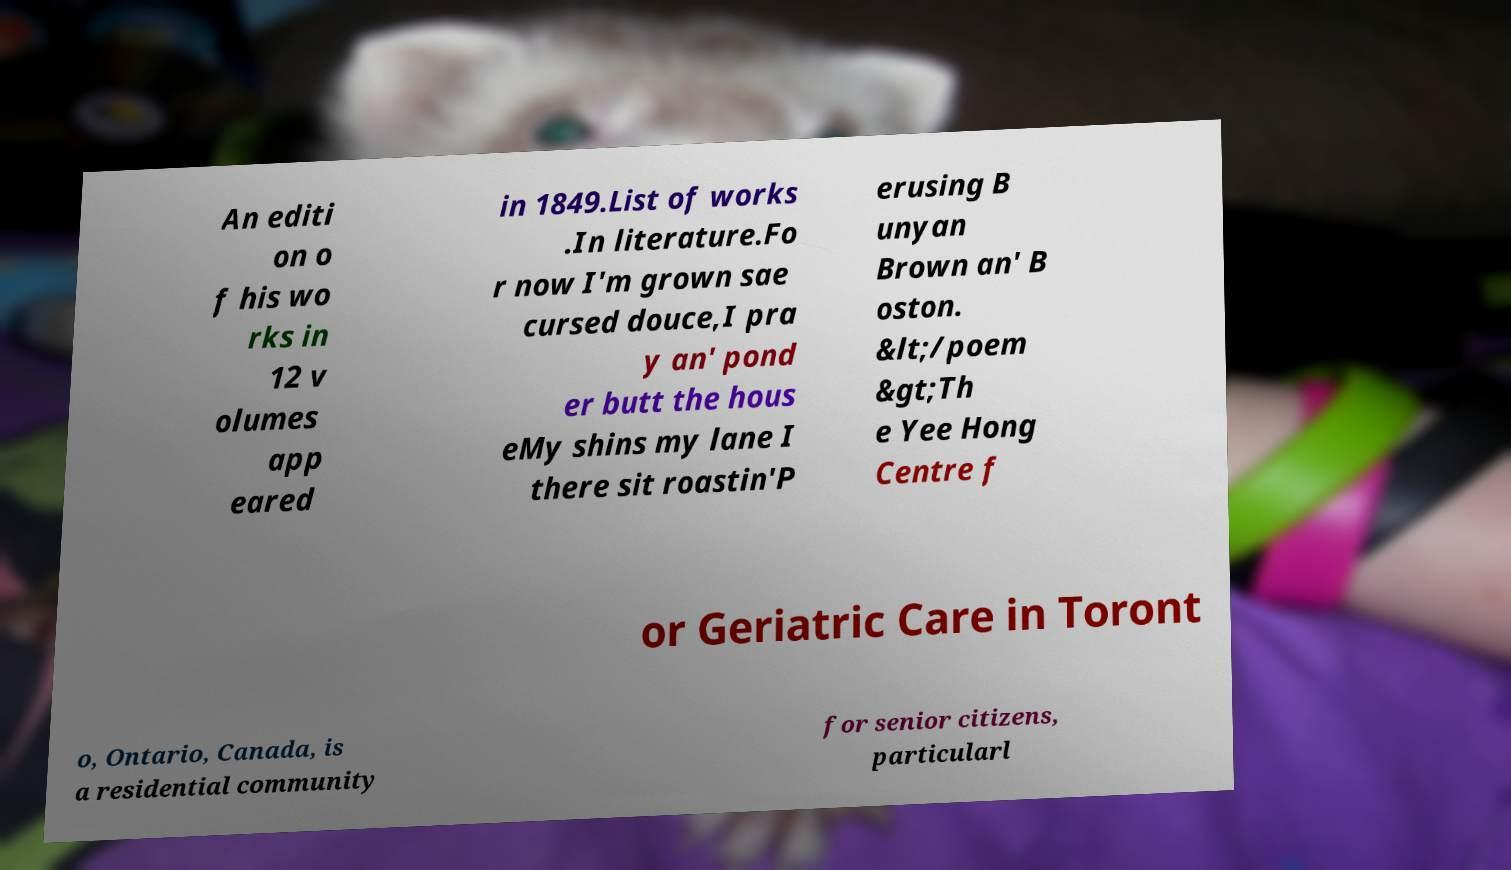What messages or text are displayed in this image? I need them in a readable, typed format. An editi on o f his wo rks in 12 v olumes app eared in 1849.List of works .In literature.Fo r now I'm grown sae cursed douce,I pra y an' pond er butt the hous eMy shins my lane I there sit roastin'P erusing B unyan Brown an' B oston. &lt;/poem &gt;Th e Yee Hong Centre f or Geriatric Care in Toront o, Ontario, Canada, is a residential community for senior citizens, particularl 